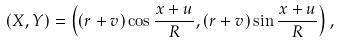Convert formula to latex. <formula><loc_0><loc_0><loc_500><loc_500>( X , Y ) = \left ( ( r + v ) \cos \frac { x + u } { R } , ( r + v ) \sin \frac { x + u } { R } \right ) ,</formula> 